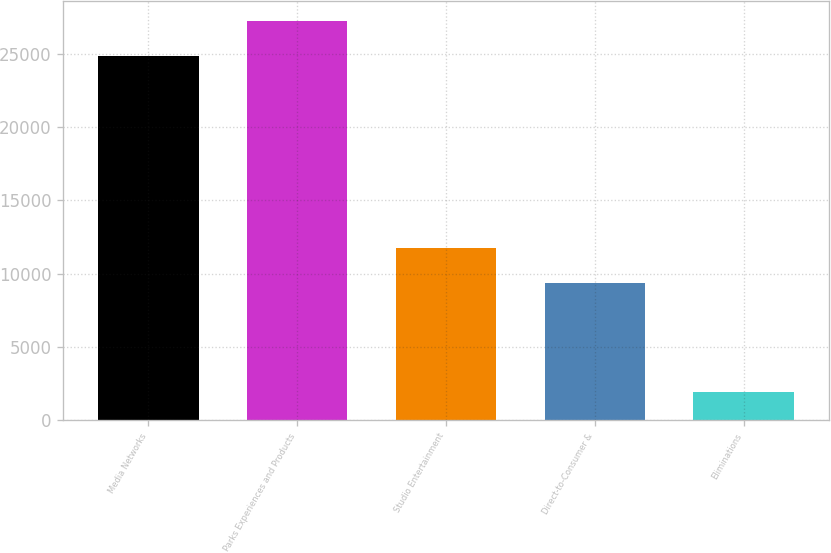Convert chart to OTSL. <chart><loc_0><loc_0><loc_500><loc_500><bar_chart><fcel>Media Networks<fcel>Parks Experiences and Products<fcel>Studio Entertainment<fcel>Direct-to-Consumer &<fcel>Eliminations<nl><fcel>24827<fcel>27253.7<fcel>11775.7<fcel>9349<fcel>1958<nl></chart> 